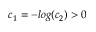Convert formula to latex. <formula><loc_0><loc_0><loc_500><loc_500>c _ { 1 } = - \log ( c _ { 2 } ) > 0</formula> 